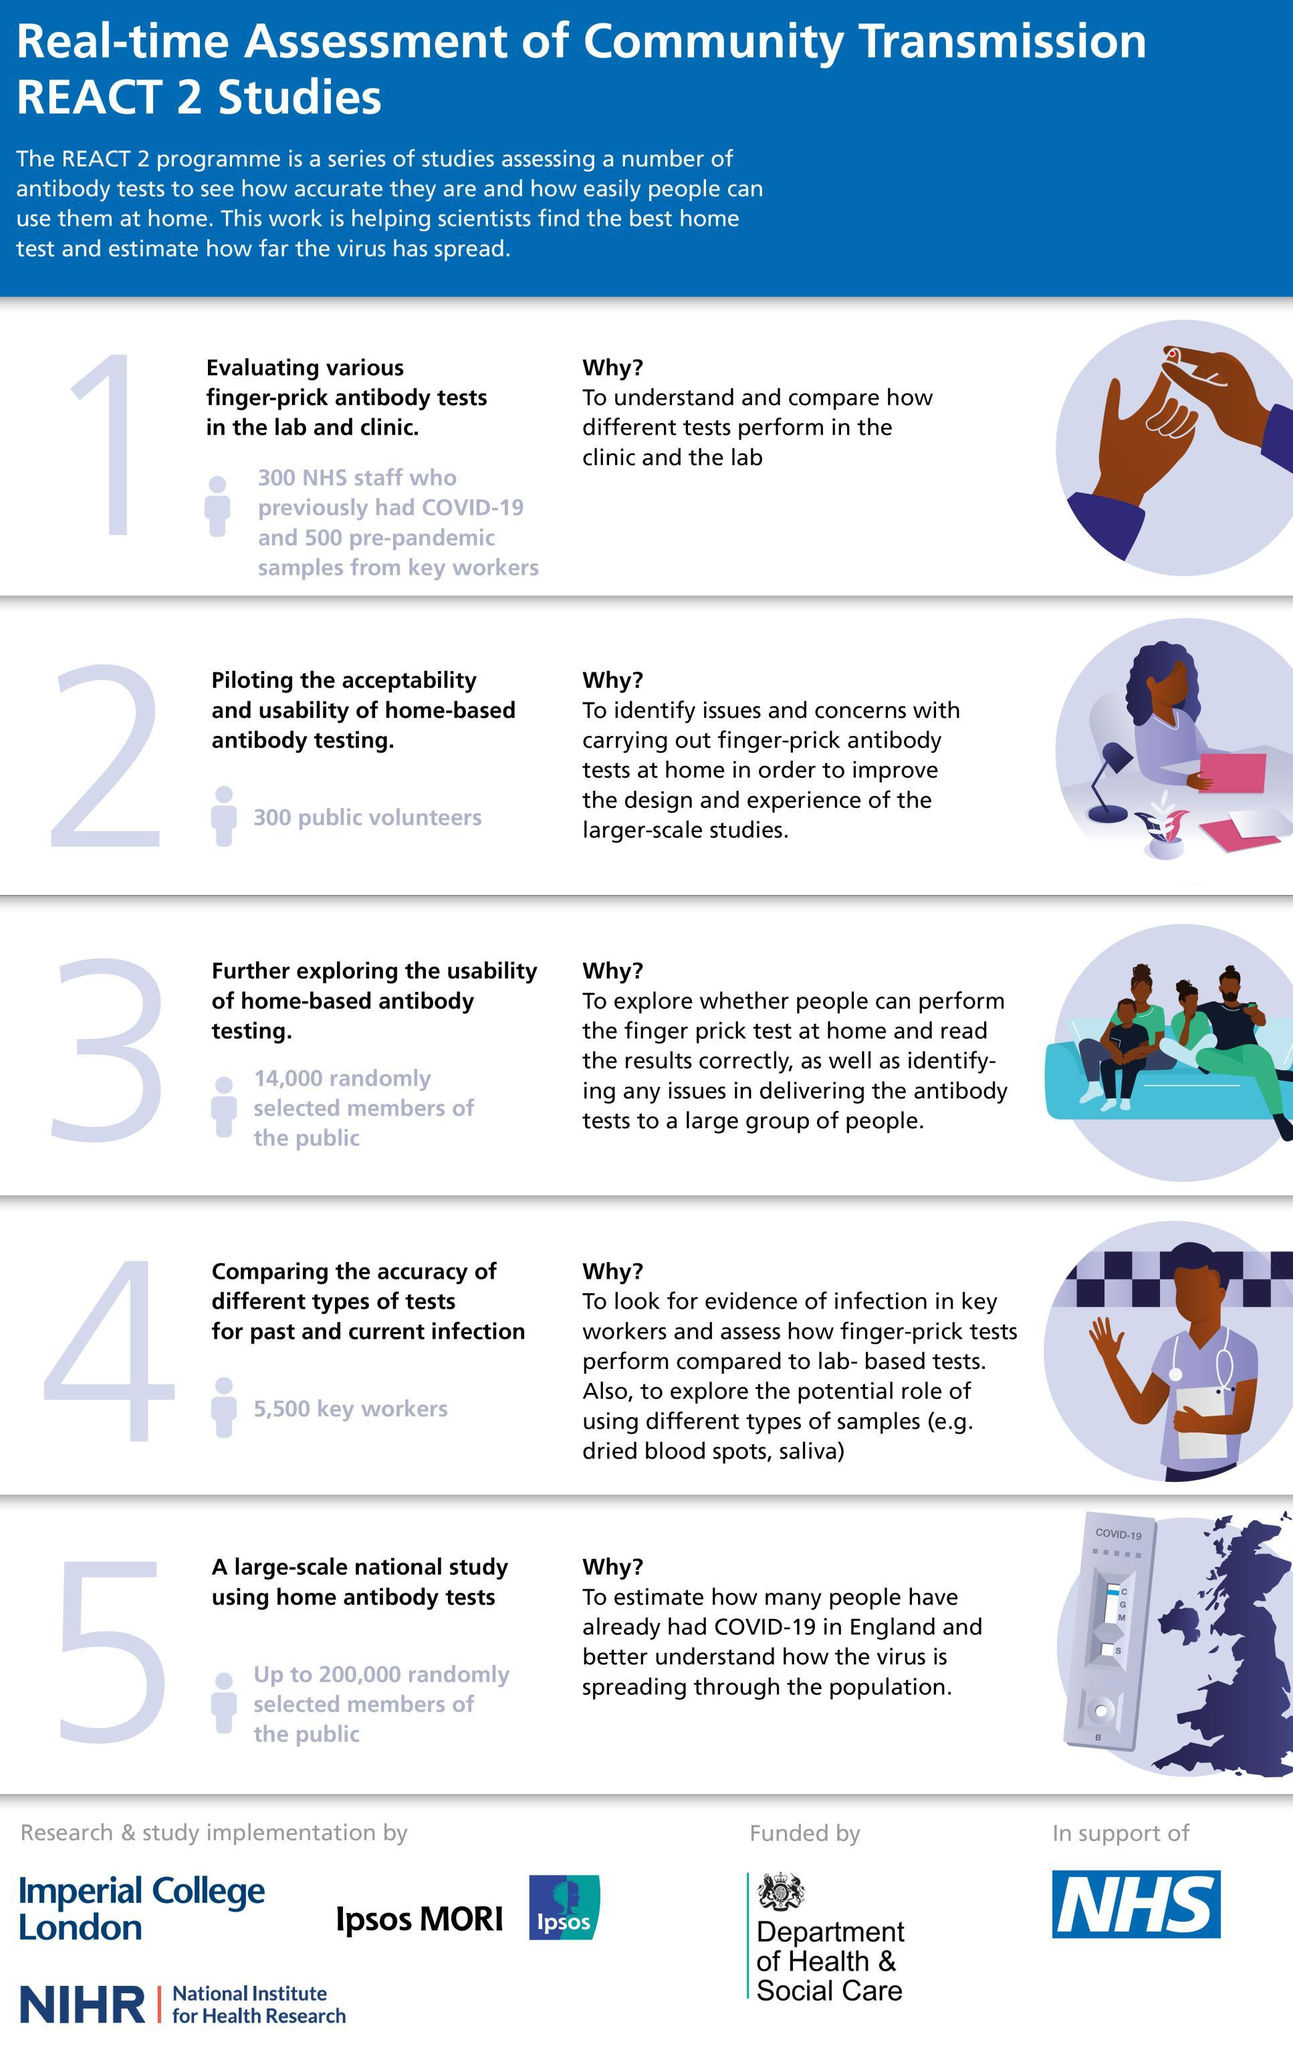Who assisted in further exploring the usability of home-based antibody testing
Answer the question with a short phrase. 14,000 randomly selected members of public how many randomly selected members of the public were used in step 5 when compared to step 3 186000 who were used for piloting the acceptability and usability of home-based antibody testing 300 public volunteers 